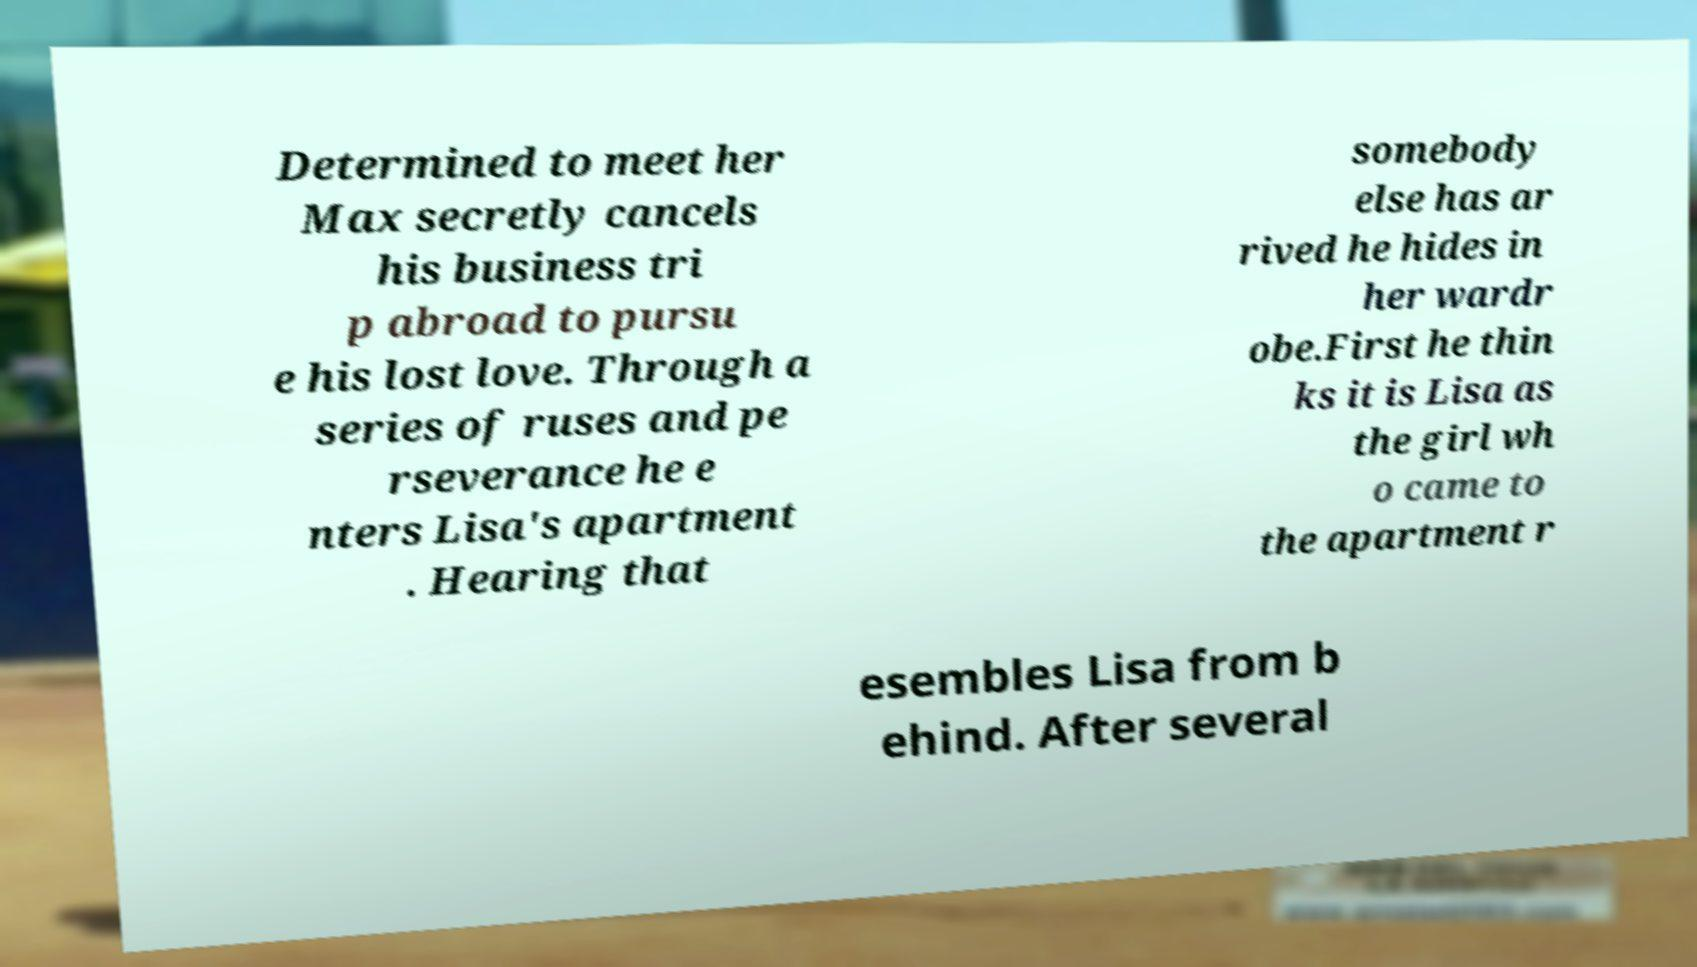Please read and relay the text visible in this image. What does it say? Determined to meet her Max secretly cancels his business tri p abroad to pursu e his lost love. Through a series of ruses and pe rseverance he e nters Lisa's apartment . Hearing that somebody else has ar rived he hides in her wardr obe.First he thin ks it is Lisa as the girl wh o came to the apartment r esembles Lisa from b ehind. After several 